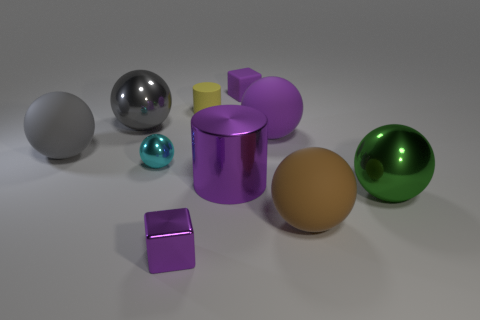Subtract all big gray metal balls. How many balls are left? 5 Subtract all brown blocks. How many gray balls are left? 2 Subtract all gray balls. How many balls are left? 4 Subtract all cubes. How many objects are left? 8 Subtract 2 spheres. How many spheres are left? 4 Subtract all blue cubes. Subtract all yellow cylinders. How many cubes are left? 2 Add 4 gray balls. How many gray balls are left? 6 Add 6 cyan metallic objects. How many cyan metallic objects exist? 7 Subtract 0 yellow cubes. How many objects are left? 10 Subtract all purple metal cubes. Subtract all large gray matte things. How many objects are left? 8 